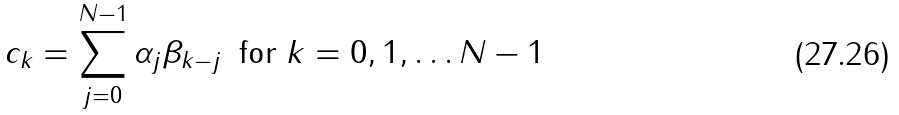<formula> <loc_0><loc_0><loc_500><loc_500>c _ { k } = \sum _ { j = 0 } ^ { N - 1 } \alpha _ { j } \beta _ { k - j } \, \text { for } k = 0 , 1 , \dots N - 1</formula> 